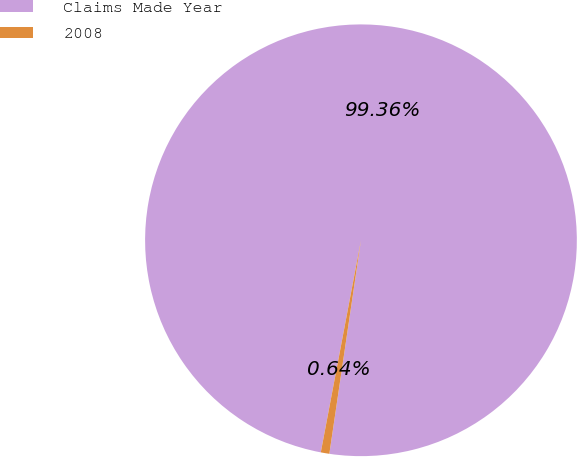Convert chart to OTSL. <chart><loc_0><loc_0><loc_500><loc_500><pie_chart><fcel>Claims Made Year<fcel>2008<nl><fcel>99.36%<fcel>0.64%<nl></chart> 